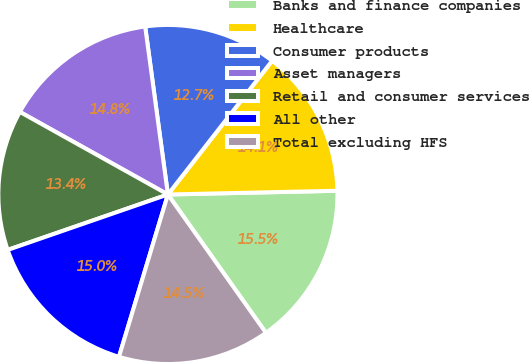Convert chart to OTSL. <chart><loc_0><loc_0><loc_500><loc_500><pie_chart><fcel>Banks and finance companies<fcel>Healthcare<fcel>Consumer products<fcel>Asset managers<fcel>Retail and consumer services<fcel>All other<fcel>Total excluding HFS<nl><fcel>15.54%<fcel>14.11%<fcel>12.68%<fcel>14.76%<fcel>13.4%<fcel>15.04%<fcel>14.47%<nl></chart> 